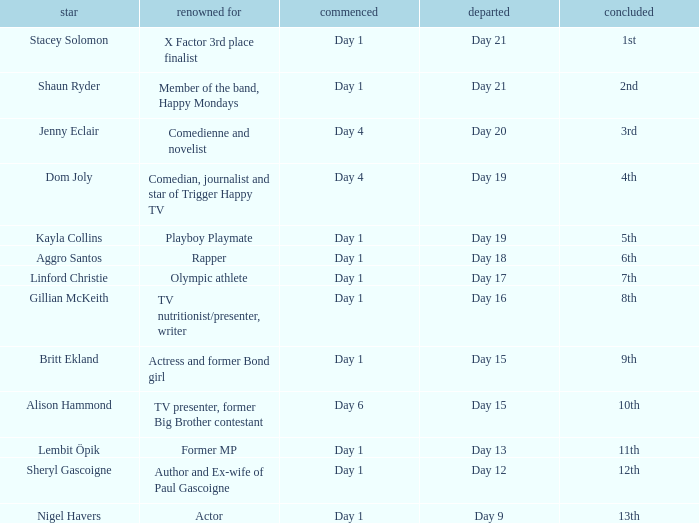What position did the celebrity finish that entered on day 1 and exited on day 19? 5th. 